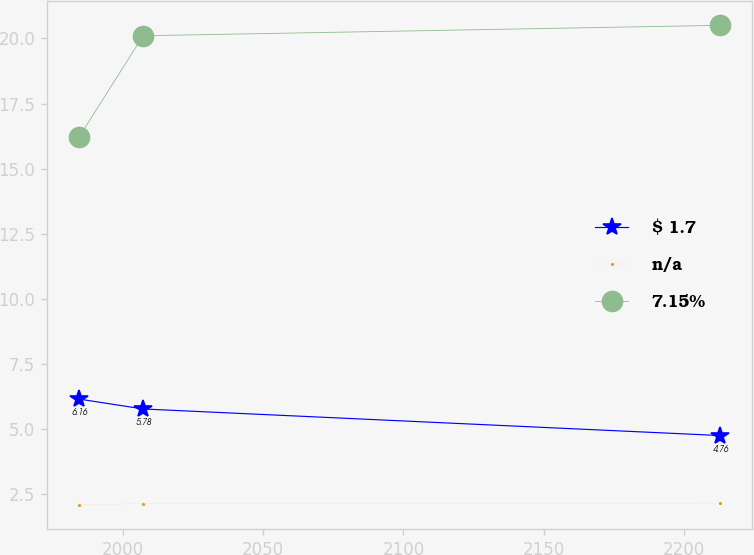Convert chart. <chart><loc_0><loc_0><loc_500><loc_500><line_chart><ecel><fcel>$ 1.7<fcel>n/a<fcel>7.15%<nl><fcel>1984.36<fcel>6.16<fcel>2.1<fcel>16.21<nl><fcel>2007.22<fcel>5.78<fcel>2.15<fcel>20.1<nl><fcel>2212.97<fcel>4.76<fcel>2.17<fcel>20.5<nl></chart> 